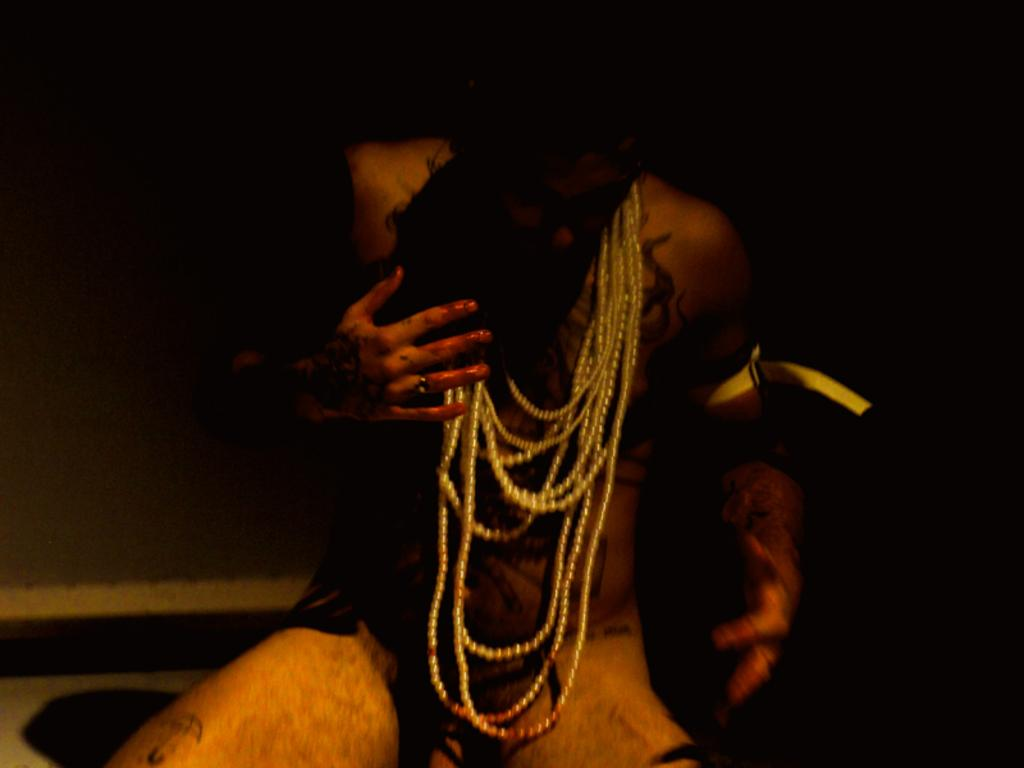Who or what is the main subject of the image? There is a person in the image. What is the person wearing or holding in the image? The person is wearing ornaments. What can be seen in the background of the image? The background of the image is dark. What is visible at the bottom of the image? There is a floor visible at the bottom of the image. How many drawers are visible in the image? There are no drawers present in the image. What team is the person playing for in the image? There is no indication of a team or any sports activity in the image. 